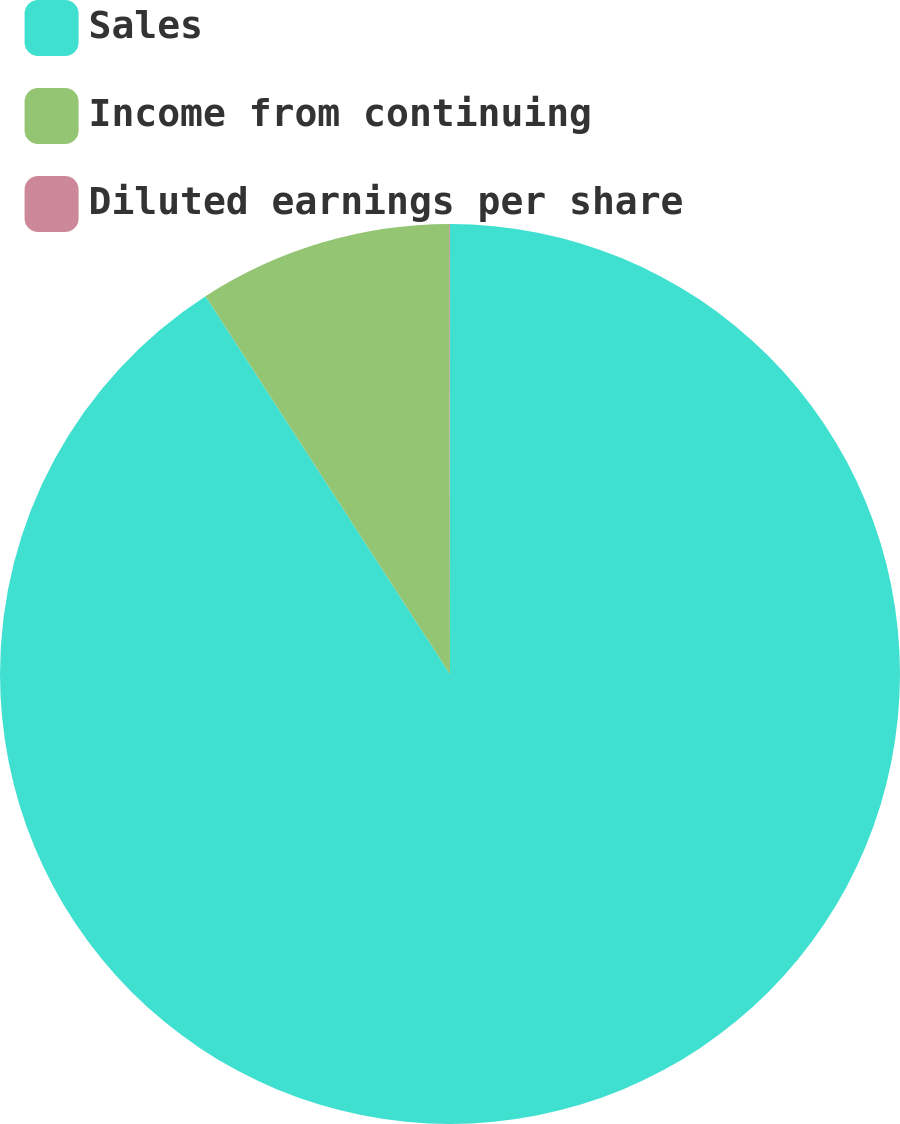Convert chart to OTSL. <chart><loc_0><loc_0><loc_500><loc_500><pie_chart><fcel>Sales<fcel>Income from continuing<fcel>Diluted earnings per share<nl><fcel>90.85%<fcel>9.11%<fcel>0.03%<nl></chart> 